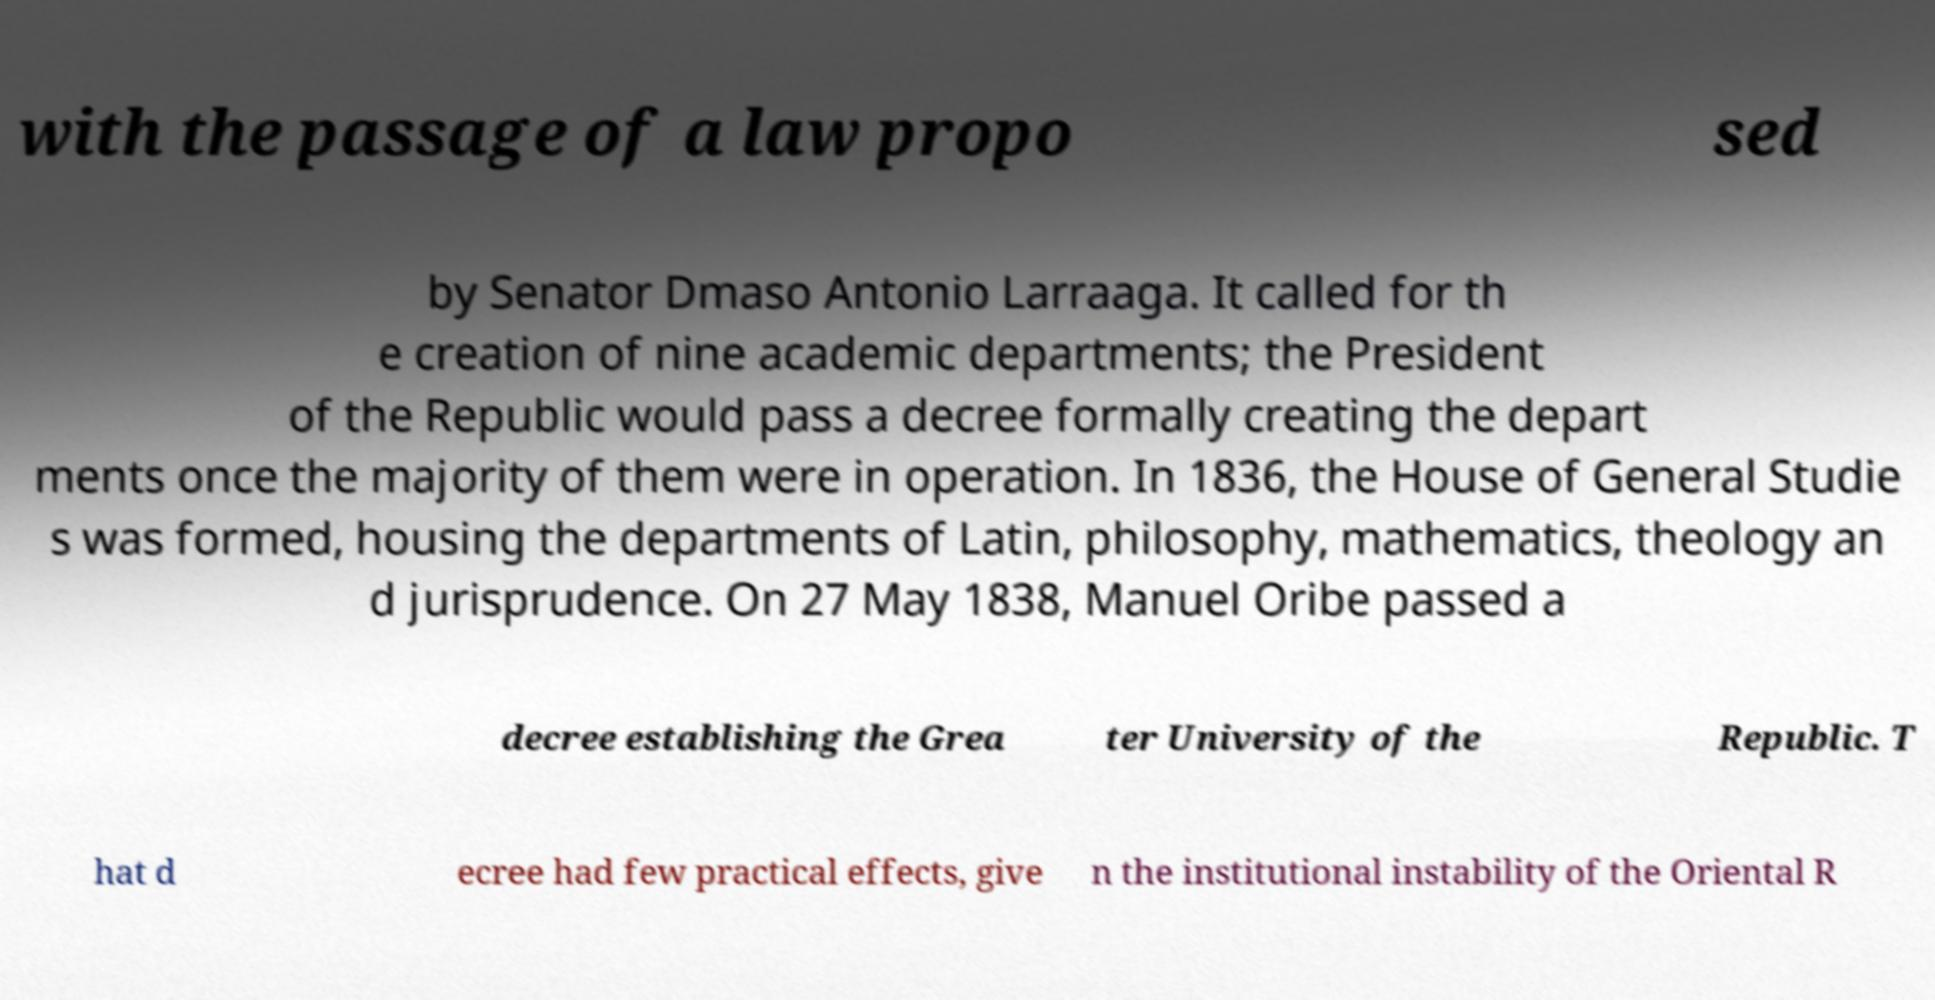Can you accurately transcribe the text from the provided image for me? with the passage of a law propo sed by Senator Dmaso Antonio Larraaga. It called for th e creation of nine academic departments; the President of the Republic would pass a decree formally creating the depart ments once the majority of them were in operation. In 1836, the House of General Studie s was formed, housing the departments of Latin, philosophy, mathematics, theology an d jurisprudence. On 27 May 1838, Manuel Oribe passed a decree establishing the Grea ter University of the Republic. T hat d ecree had few practical effects, give n the institutional instability of the Oriental R 